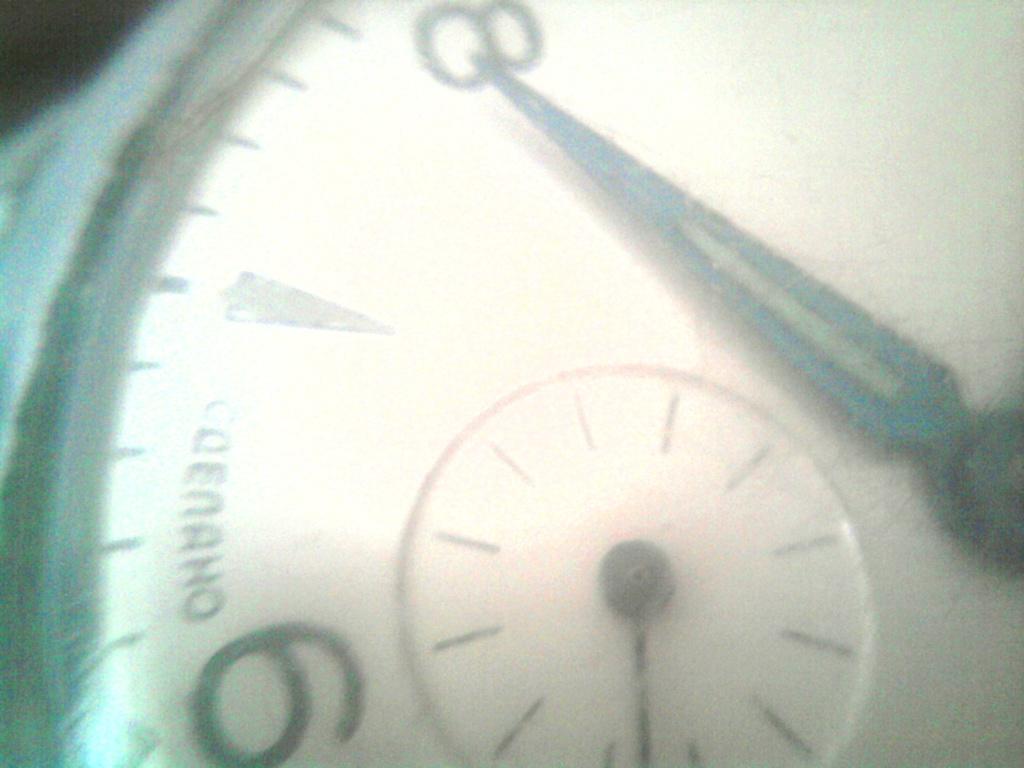Which number is the clock hand pointing to?
Your answer should be compact. 8. 